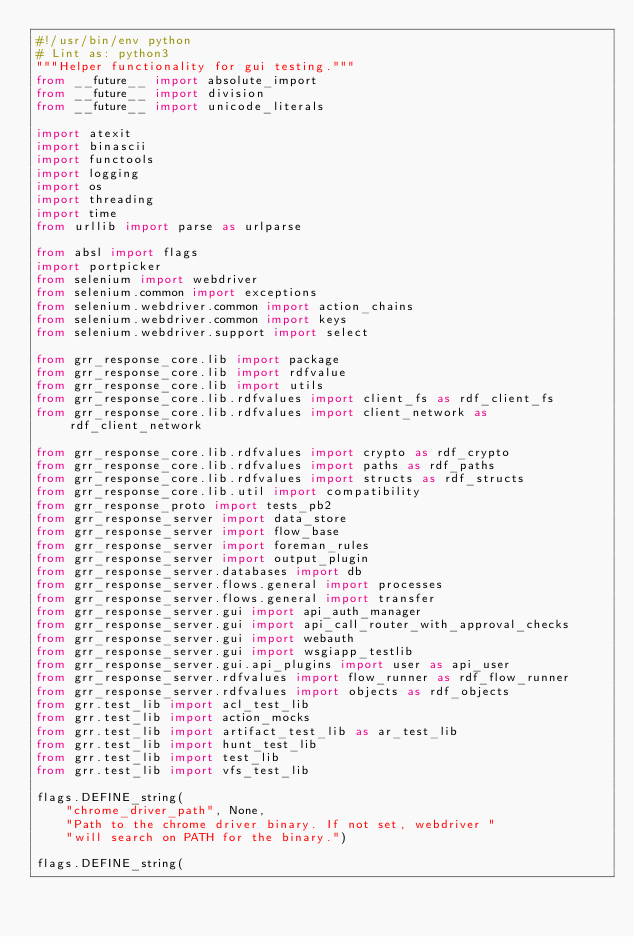Convert code to text. <code><loc_0><loc_0><loc_500><loc_500><_Python_>#!/usr/bin/env python
# Lint as: python3
"""Helper functionality for gui testing."""
from __future__ import absolute_import
from __future__ import division
from __future__ import unicode_literals

import atexit
import binascii
import functools
import logging
import os
import threading
import time
from urllib import parse as urlparse

from absl import flags
import portpicker
from selenium import webdriver
from selenium.common import exceptions
from selenium.webdriver.common import action_chains
from selenium.webdriver.common import keys
from selenium.webdriver.support import select

from grr_response_core.lib import package
from grr_response_core.lib import rdfvalue
from grr_response_core.lib import utils
from grr_response_core.lib.rdfvalues import client_fs as rdf_client_fs
from grr_response_core.lib.rdfvalues import client_network as rdf_client_network

from grr_response_core.lib.rdfvalues import crypto as rdf_crypto
from grr_response_core.lib.rdfvalues import paths as rdf_paths
from grr_response_core.lib.rdfvalues import structs as rdf_structs
from grr_response_core.lib.util import compatibility
from grr_response_proto import tests_pb2
from grr_response_server import data_store
from grr_response_server import flow_base
from grr_response_server import foreman_rules
from grr_response_server import output_plugin
from grr_response_server.databases import db
from grr_response_server.flows.general import processes
from grr_response_server.flows.general import transfer
from grr_response_server.gui import api_auth_manager
from grr_response_server.gui import api_call_router_with_approval_checks
from grr_response_server.gui import webauth
from grr_response_server.gui import wsgiapp_testlib
from grr_response_server.gui.api_plugins import user as api_user
from grr_response_server.rdfvalues import flow_runner as rdf_flow_runner
from grr_response_server.rdfvalues import objects as rdf_objects
from grr.test_lib import acl_test_lib
from grr.test_lib import action_mocks
from grr.test_lib import artifact_test_lib as ar_test_lib
from grr.test_lib import hunt_test_lib
from grr.test_lib import test_lib
from grr.test_lib import vfs_test_lib

flags.DEFINE_string(
    "chrome_driver_path", None,
    "Path to the chrome driver binary. If not set, webdriver "
    "will search on PATH for the binary.")

flags.DEFINE_string(</code> 